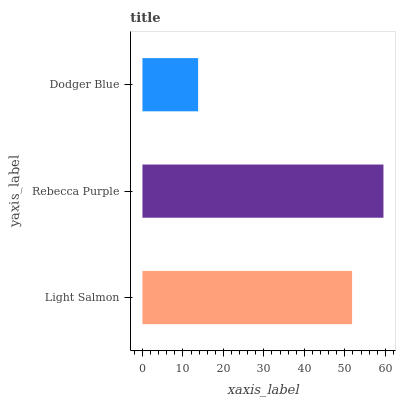Is Dodger Blue the minimum?
Answer yes or no. Yes. Is Rebecca Purple the maximum?
Answer yes or no. Yes. Is Rebecca Purple the minimum?
Answer yes or no. No. Is Dodger Blue the maximum?
Answer yes or no. No. Is Rebecca Purple greater than Dodger Blue?
Answer yes or no. Yes. Is Dodger Blue less than Rebecca Purple?
Answer yes or no. Yes. Is Dodger Blue greater than Rebecca Purple?
Answer yes or no. No. Is Rebecca Purple less than Dodger Blue?
Answer yes or no. No. Is Light Salmon the high median?
Answer yes or no. Yes. Is Light Salmon the low median?
Answer yes or no. Yes. Is Dodger Blue the high median?
Answer yes or no. No. Is Dodger Blue the low median?
Answer yes or no. No. 